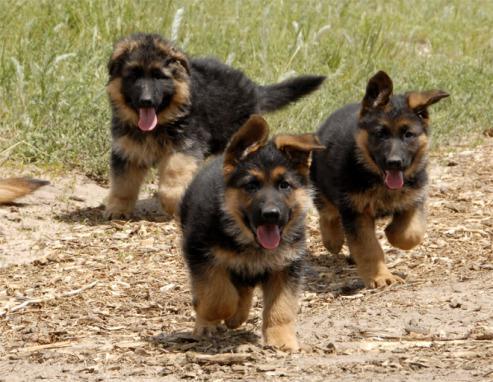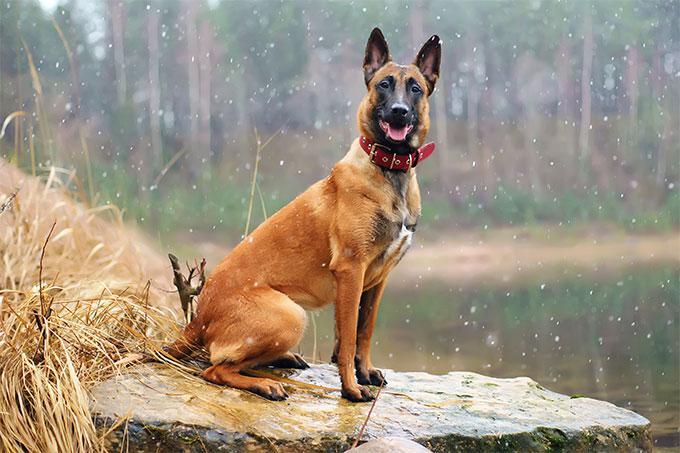The first image is the image on the left, the second image is the image on the right. For the images shown, is this caption "There are three dogs in one of the images." true? Answer yes or no. Yes. 